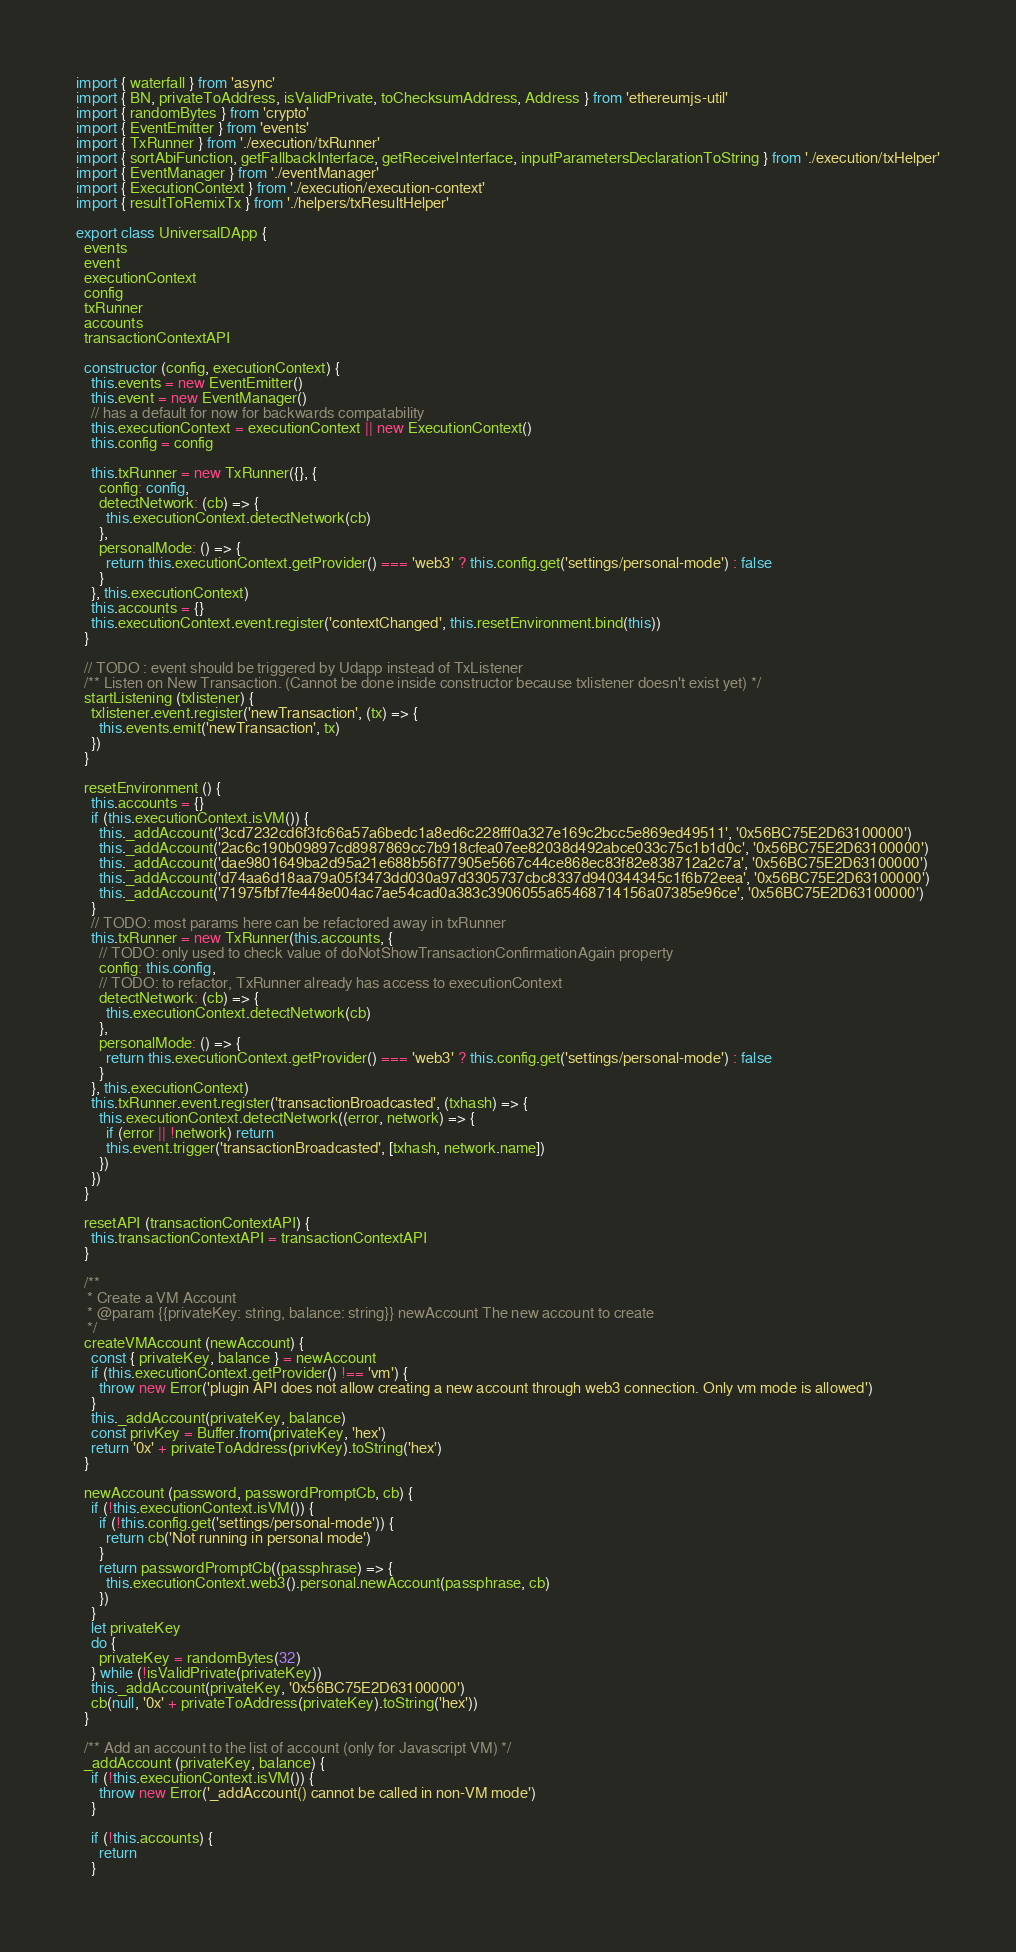Convert code to text. <code><loc_0><loc_0><loc_500><loc_500><_TypeScript_>import { waterfall } from 'async'
import { BN, privateToAddress, isValidPrivate, toChecksumAddress, Address } from 'ethereumjs-util'
import { randomBytes } from 'crypto'
import { EventEmitter } from 'events'
import { TxRunner } from './execution/txRunner'
import { sortAbiFunction, getFallbackInterface, getReceiveInterface, inputParametersDeclarationToString } from './execution/txHelper'
import { EventManager } from './eventManager'
import { ExecutionContext } from './execution/execution-context'
import { resultToRemixTx } from './helpers/txResultHelper'

export class UniversalDApp {
  events
  event
  executionContext
  config
  txRunner
  accounts
  transactionContextAPI

  constructor (config, executionContext) {
    this.events = new EventEmitter()
    this.event = new EventManager()
    // has a default for now for backwards compatability
    this.executionContext = executionContext || new ExecutionContext()
    this.config = config

    this.txRunner = new TxRunner({}, {
      config: config,
      detectNetwork: (cb) => {
        this.executionContext.detectNetwork(cb)
      },
      personalMode: () => {
        return this.executionContext.getProvider() === 'web3' ? this.config.get('settings/personal-mode') : false
      }
    }, this.executionContext)
    this.accounts = {}
    this.executionContext.event.register('contextChanged', this.resetEnvironment.bind(this))
  }

  // TODO : event should be triggered by Udapp instead of TxListener
  /** Listen on New Transaction. (Cannot be done inside constructor because txlistener doesn't exist yet) */
  startListening (txlistener) {
    txlistener.event.register('newTransaction', (tx) => {
      this.events.emit('newTransaction', tx)
    })
  }

  resetEnvironment () {
    this.accounts = {}
    if (this.executionContext.isVM()) {
      this._addAccount('3cd7232cd6f3fc66a57a6bedc1a8ed6c228fff0a327e169c2bcc5e869ed49511', '0x56BC75E2D63100000')
      this._addAccount('2ac6c190b09897cd8987869cc7b918cfea07ee82038d492abce033c75c1b1d0c', '0x56BC75E2D63100000')
      this._addAccount('dae9801649ba2d95a21e688b56f77905e5667c44ce868ec83f82e838712a2c7a', '0x56BC75E2D63100000')
      this._addAccount('d74aa6d18aa79a05f3473dd030a97d3305737cbc8337d940344345c1f6b72eea', '0x56BC75E2D63100000')
      this._addAccount('71975fbf7fe448e004ac7ae54cad0a383c3906055a65468714156a07385e96ce', '0x56BC75E2D63100000')
    }
    // TODO: most params here can be refactored away in txRunner
    this.txRunner = new TxRunner(this.accounts, {
      // TODO: only used to check value of doNotShowTransactionConfirmationAgain property
      config: this.config,
      // TODO: to refactor, TxRunner already has access to executionContext
      detectNetwork: (cb) => {
        this.executionContext.detectNetwork(cb)
      },
      personalMode: () => {
        return this.executionContext.getProvider() === 'web3' ? this.config.get('settings/personal-mode') : false
      }
    }, this.executionContext)
    this.txRunner.event.register('transactionBroadcasted', (txhash) => {
      this.executionContext.detectNetwork((error, network) => {
        if (error || !network) return
        this.event.trigger('transactionBroadcasted', [txhash, network.name])
      })
    })
  }

  resetAPI (transactionContextAPI) {
    this.transactionContextAPI = transactionContextAPI
  }

  /**
   * Create a VM Account
   * @param {{privateKey: string, balance: string}} newAccount The new account to create
   */
  createVMAccount (newAccount) {
    const { privateKey, balance } = newAccount
    if (this.executionContext.getProvider() !== 'vm') {
      throw new Error('plugin API does not allow creating a new account through web3 connection. Only vm mode is allowed')
    }
    this._addAccount(privateKey, balance)
    const privKey = Buffer.from(privateKey, 'hex')
    return '0x' + privateToAddress(privKey).toString('hex')
  }

  newAccount (password, passwordPromptCb, cb) {
    if (!this.executionContext.isVM()) {
      if (!this.config.get('settings/personal-mode')) {
        return cb('Not running in personal mode')
      }
      return passwordPromptCb((passphrase) => {
        this.executionContext.web3().personal.newAccount(passphrase, cb)
      })
    }
    let privateKey
    do {
      privateKey = randomBytes(32)
    } while (!isValidPrivate(privateKey))
    this._addAccount(privateKey, '0x56BC75E2D63100000')
    cb(null, '0x' + privateToAddress(privateKey).toString('hex'))
  }

  /** Add an account to the list of account (only for Javascript VM) */
  _addAccount (privateKey, balance) {
    if (!this.executionContext.isVM()) {
      throw new Error('_addAccount() cannot be called in non-VM mode')
    }

    if (!this.accounts) {
      return
    }</code> 